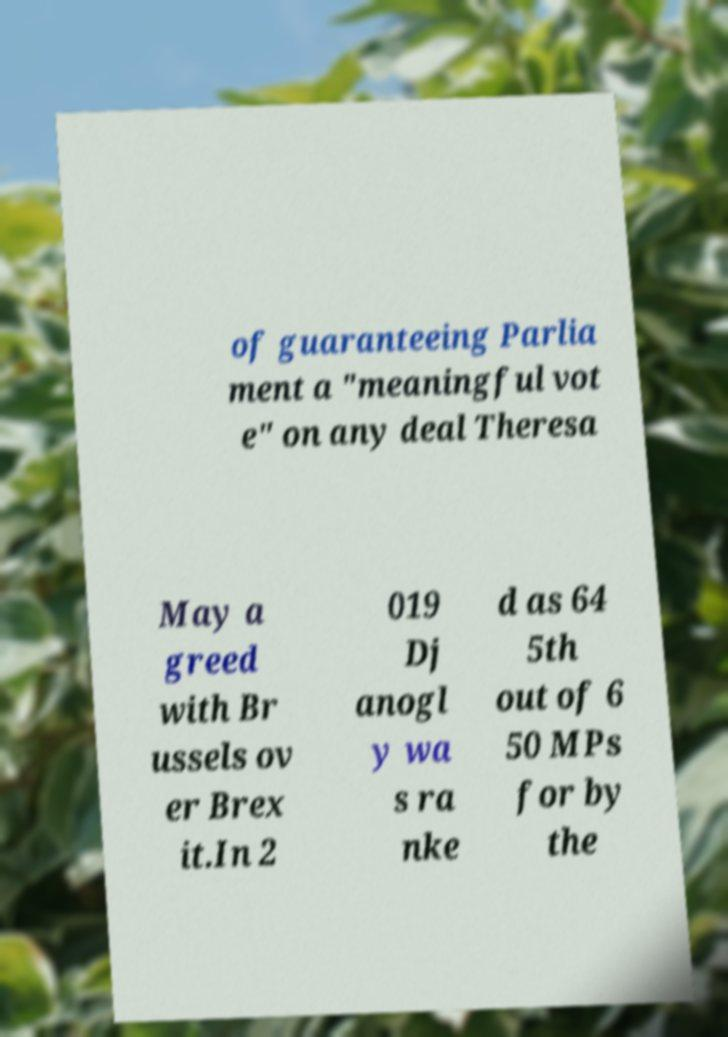Please identify and transcribe the text found in this image. of guaranteeing Parlia ment a "meaningful vot e" on any deal Theresa May a greed with Br ussels ov er Brex it.In 2 019 Dj anogl y wa s ra nke d as 64 5th out of 6 50 MPs for by the 